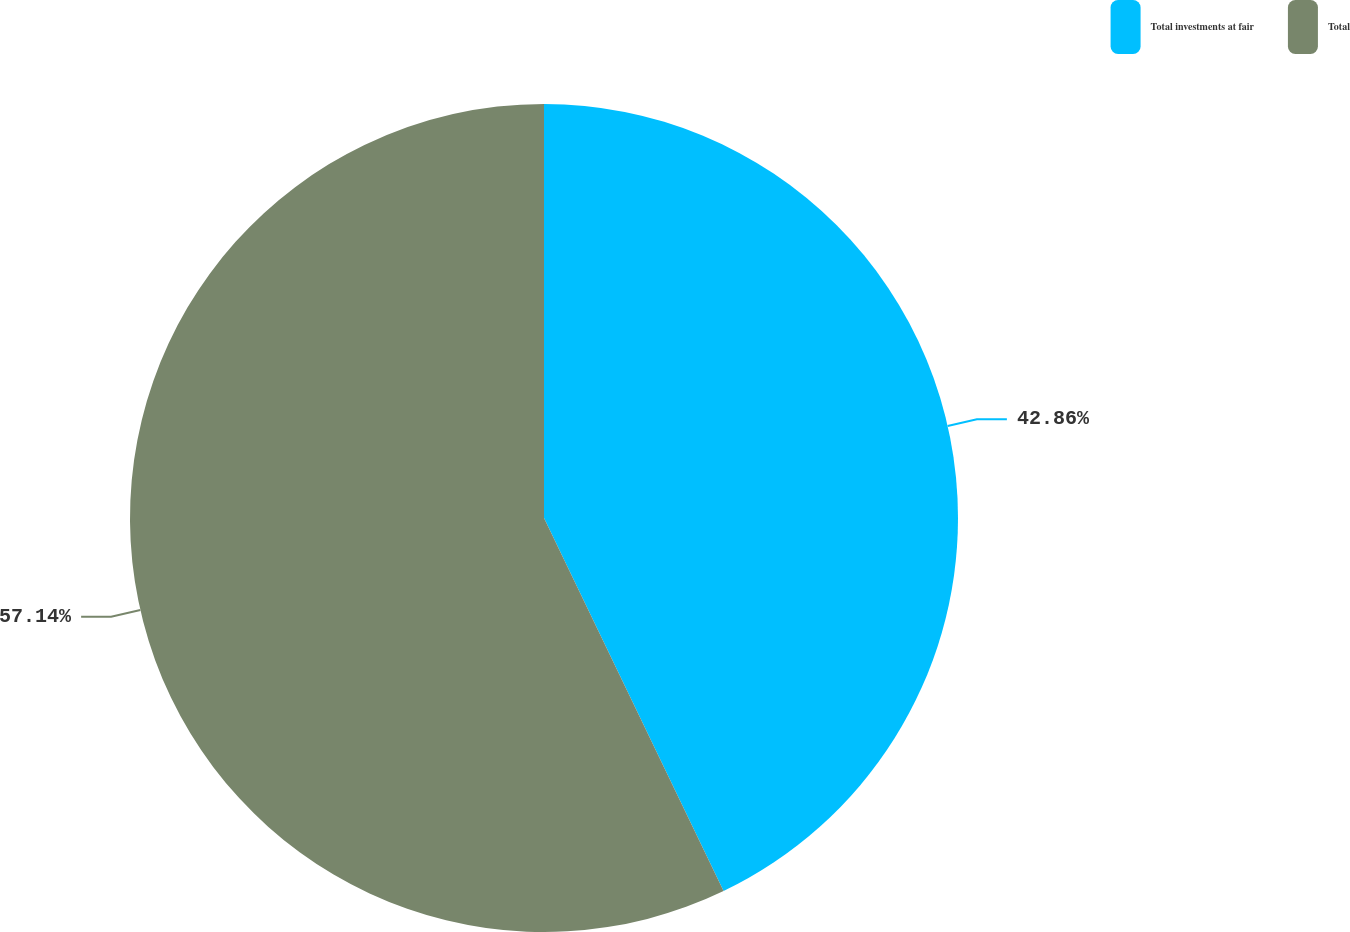Convert chart to OTSL. <chart><loc_0><loc_0><loc_500><loc_500><pie_chart><fcel>Total investments at fair<fcel>Total<nl><fcel>42.86%<fcel>57.14%<nl></chart> 